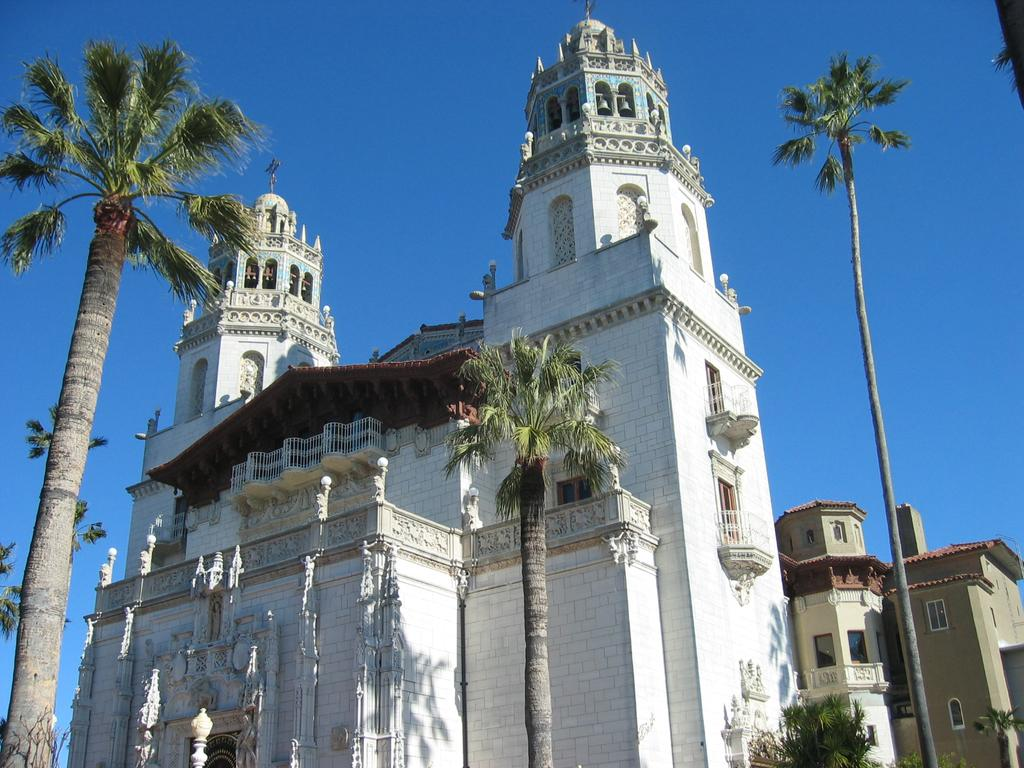What is the color of the building in the picture? The building in the picture is white. What other elements can be seen in the picture besides the building? There are trees in the picture. What can be seen in the background of the picture? The sky is visible in the background of the picture. What is the price of the operation being performed on the tray in the picture? There is no tray or operation present in the image; it features a white building and trees with the sky visible in the background. 